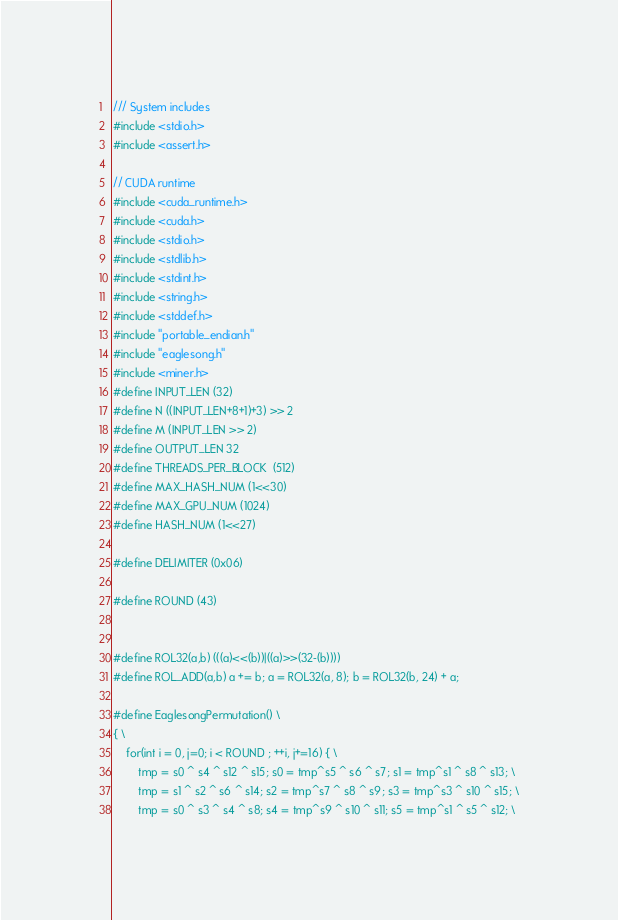Convert code to text. <code><loc_0><loc_0><loc_500><loc_500><_Cuda_>/// System includes
#include <stdio.h>
#include <assert.h>

// CUDA runtime
#include <cuda_runtime.h>
#include <cuda.h>
#include <stdio.h>
#include <stdlib.h>
#include <stdint.h>
#include <string.h>
#include <stddef.h>
#include "portable_endian.h"
#include "eaglesong.h"
#include <miner.h>
#define INPUT_LEN (32)
#define N ((INPUT_LEN+8+1)+3) >> 2
#define M (INPUT_LEN >> 2)
#define OUTPUT_LEN 32
#define THREADS_PER_BLOCK  (512)
#define MAX_HASH_NUM (1<<30)
#define MAX_GPU_NUM (1024)
#define HASH_NUM (1<<27)

#define DELIMITER (0x06)

#define ROUND (43)


#define ROL32(a,b) (((a)<<(b))|((a)>>(32-(b))))
#define ROL_ADD(a,b) a += b; a = ROL32(a, 8); b = ROL32(b, 24) + a;

#define EaglesongPermutation() \
{ \
	for(int i = 0, j=0; i < ROUND ; ++i, j+=16) { \
		tmp = s0 ^ s4 ^ s12 ^ s15; s0 = tmp^s5 ^ s6 ^ s7; s1 = tmp^s1 ^ s8 ^ s13; \
		tmp = s1 ^ s2 ^ s6 ^ s14; s2 = tmp^s7 ^ s8 ^ s9; s3 = tmp^s3 ^ s10 ^ s15; \
		tmp = s0 ^ s3 ^ s4 ^ s8; s4 = tmp^s9 ^ s10 ^ s11; s5 = tmp^s1 ^ s5 ^ s12; \</code> 